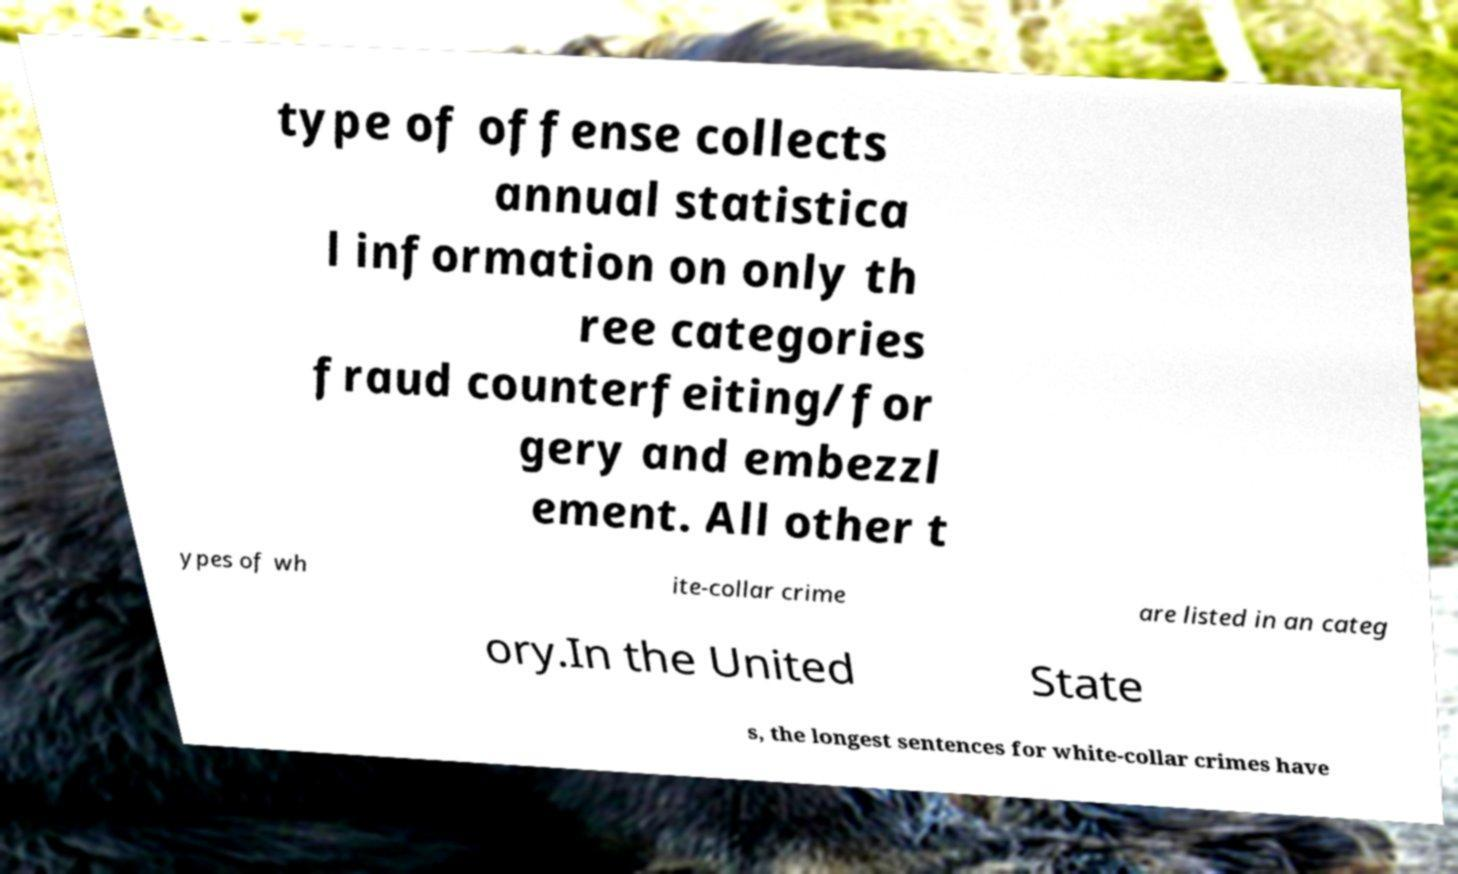Can you accurately transcribe the text from the provided image for me? type of offense collects annual statistica l information on only th ree categories fraud counterfeiting/for gery and embezzl ement. All other t ypes of wh ite-collar crime are listed in an categ ory.In the United State s, the longest sentences for white-collar crimes have 